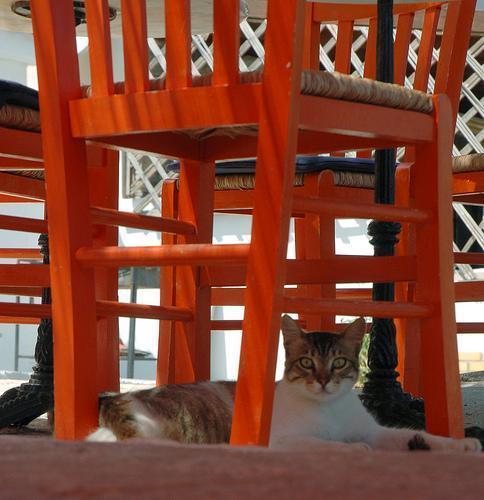How many chairs are at least partially visible?
Give a very brief answer. 5. How many cats are there?
Give a very brief answer. 1. How many of cat eyes are visible?
Give a very brief answer. 2. 